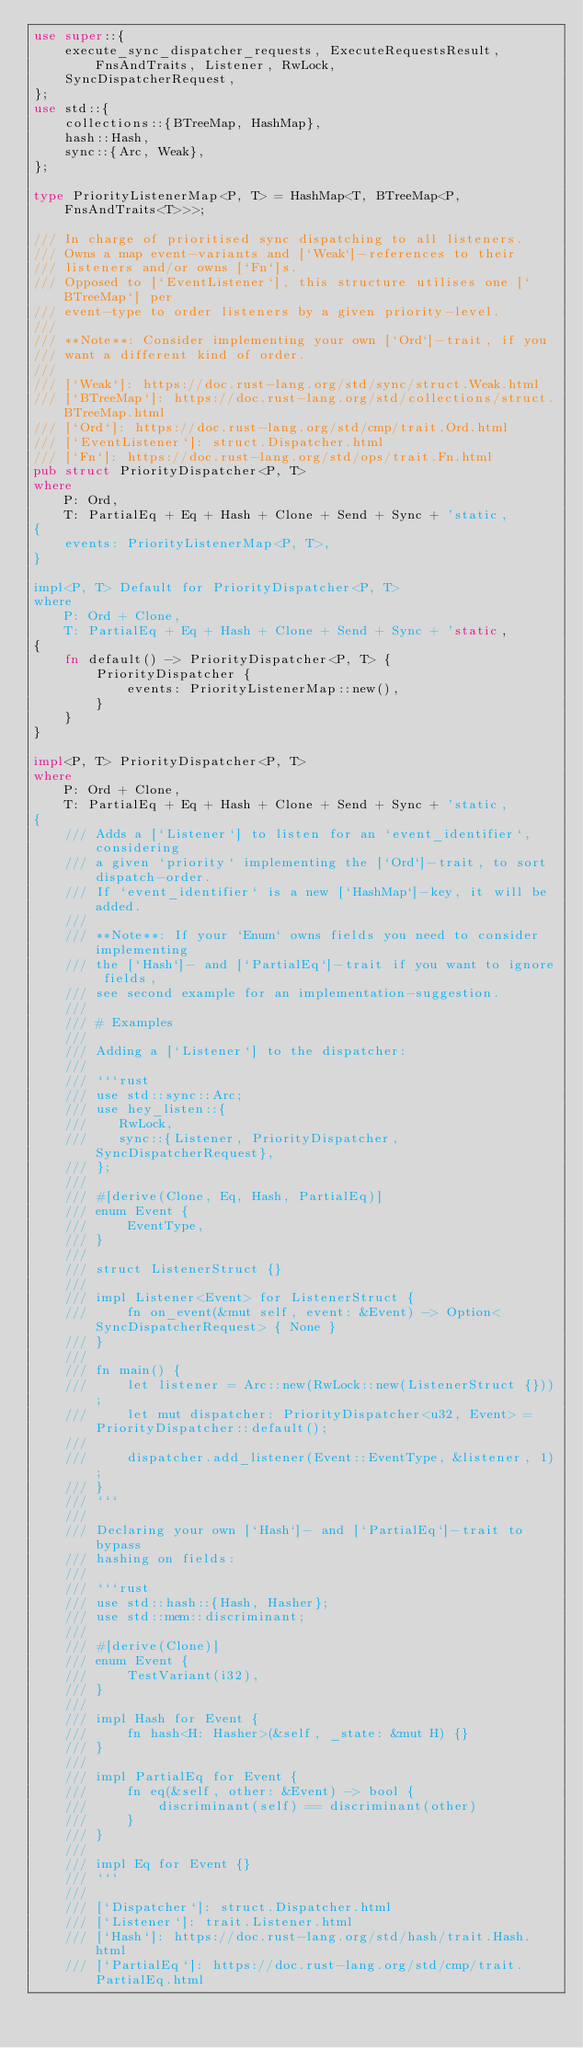<code> <loc_0><loc_0><loc_500><loc_500><_Rust_>use super::{
    execute_sync_dispatcher_requests, ExecuteRequestsResult, FnsAndTraits, Listener, RwLock,
    SyncDispatcherRequest,
};
use std::{
    collections::{BTreeMap, HashMap},
    hash::Hash,
    sync::{Arc, Weak},
};

type PriorityListenerMap<P, T> = HashMap<T, BTreeMap<P, FnsAndTraits<T>>>;

/// In charge of prioritised sync dispatching to all listeners.
/// Owns a map event-variants and [`Weak`]-references to their
/// listeners and/or owns [`Fn`]s.
/// Opposed to [`EventListener`], this structure utilises one [`BTreeMap`] per
/// event-type to order listeners by a given priority-level.
///
/// **Note**: Consider implementing your own [`Ord`]-trait, if you
/// want a different kind of order.
///
/// [`Weak`]: https://doc.rust-lang.org/std/sync/struct.Weak.html
/// [`BTreeMap`]: https://doc.rust-lang.org/std/collections/struct.BTreeMap.html
/// [`Ord`]: https://doc.rust-lang.org/std/cmp/trait.Ord.html
/// [`EventListener`]: struct.Dispatcher.html
/// [`Fn`]: https://doc.rust-lang.org/std/ops/trait.Fn.html
pub struct PriorityDispatcher<P, T>
where
    P: Ord,
    T: PartialEq + Eq + Hash + Clone + Send + Sync + 'static,
{
    events: PriorityListenerMap<P, T>,
}

impl<P, T> Default for PriorityDispatcher<P, T>
where
    P: Ord + Clone,
    T: PartialEq + Eq + Hash + Clone + Send + Sync + 'static,
{
    fn default() -> PriorityDispatcher<P, T> {
        PriorityDispatcher {
            events: PriorityListenerMap::new(),
        }
    }
}

impl<P, T> PriorityDispatcher<P, T>
where
    P: Ord + Clone,
    T: PartialEq + Eq + Hash + Clone + Send + Sync + 'static,
{
    /// Adds a [`Listener`] to listen for an `event_identifier`, considering
    /// a given `priority` implementing the [`Ord`]-trait, to sort dispatch-order.
    /// If `event_identifier` is a new [`HashMap`]-key, it will be added.
    ///
    /// **Note**: If your `Enum` owns fields you need to consider implementing
    /// the [`Hash`]- and [`PartialEq`]-trait if you want to ignore fields,
    /// see second example for an implementation-suggestion.
    ///
    /// # Examples
    ///
    /// Adding a [`Listener`] to the dispatcher:
    ///
    /// ```rust
    /// use std::sync::Arc;
    /// use hey_listen::{
    ///    RwLock,
    ///    sync::{Listener, PriorityDispatcher, SyncDispatcherRequest},
    /// };
    ///
    /// #[derive(Clone, Eq, Hash, PartialEq)]
    /// enum Event {
    ///     EventType,
    /// }
    ///
    /// struct ListenerStruct {}
    ///
    /// impl Listener<Event> for ListenerStruct {
    ///     fn on_event(&mut self, event: &Event) -> Option<SyncDispatcherRequest> { None }
    /// }
    ///
    /// fn main() {
    ///     let listener = Arc::new(RwLock::new(ListenerStruct {}));
    ///     let mut dispatcher: PriorityDispatcher<u32, Event> = PriorityDispatcher::default();
    ///
    ///     dispatcher.add_listener(Event::EventType, &listener, 1);
    /// }
    /// ```
    ///
    /// Declaring your own [`Hash`]- and [`PartialEq`]-trait to bypass
    /// hashing on fields:
    ///
    /// ```rust
    /// use std::hash::{Hash, Hasher};
    /// use std::mem::discriminant;
    ///
    /// #[derive(Clone)]
    /// enum Event {
    ///     TestVariant(i32),
    /// }
    ///
    /// impl Hash for Event {
    ///     fn hash<H: Hasher>(&self, _state: &mut H) {}
    /// }
    ///
    /// impl PartialEq for Event {
    ///     fn eq(&self, other: &Event) -> bool {
    ///         discriminant(self) == discriminant(other)
    ///     }
    /// }
    ///
    /// impl Eq for Event {}
    /// ```
    ///
    /// [`Dispatcher`]: struct.Dispatcher.html
    /// [`Listener`]: trait.Listener.html
    /// [`Hash`]: https://doc.rust-lang.org/std/hash/trait.Hash.html
    /// [`PartialEq`]: https://doc.rust-lang.org/std/cmp/trait.PartialEq.html</code> 